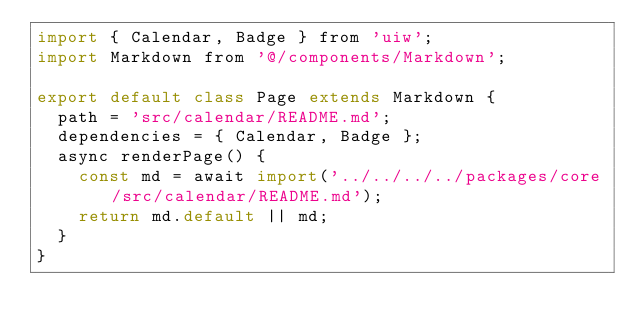<code> <loc_0><loc_0><loc_500><loc_500><_JavaScript_>import { Calendar, Badge } from 'uiw';
import Markdown from '@/components/Markdown';

export default class Page extends Markdown {
  path = 'src/calendar/README.md';
  dependencies = { Calendar, Badge };
  async renderPage() {
    const md = await import('../../../../packages/core/src/calendar/README.md');
    return md.default || md;
  }
}
</code> 